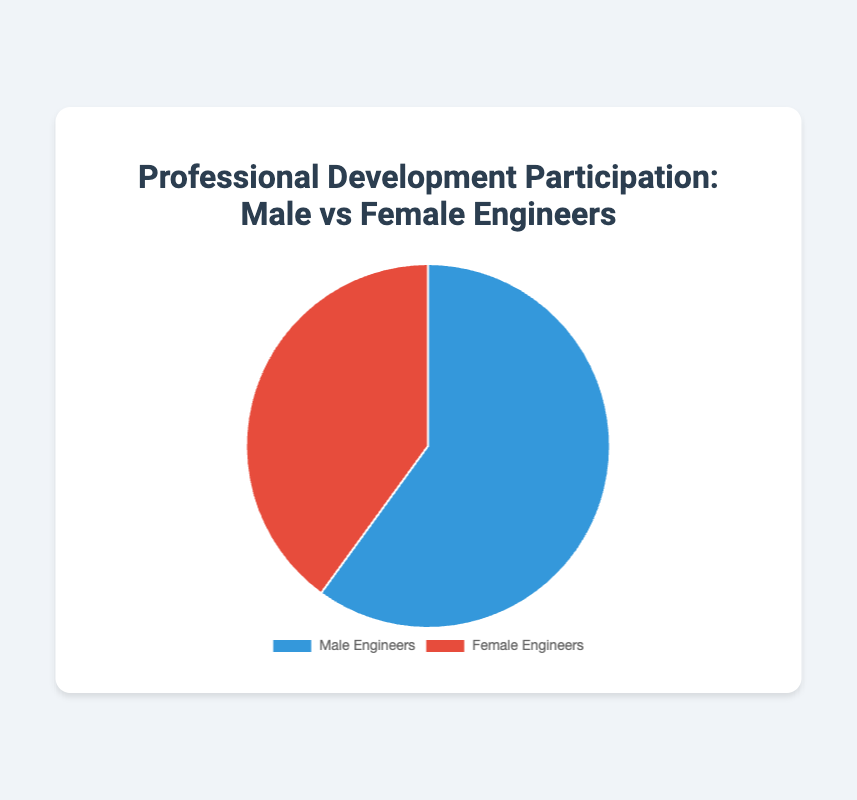What percentage of participants in professional development programs are Female Engineers? The total number of participants is 1200 (Male Engineers) + 800 (Female Engineers) = 2000. The percentage of Female Engineers is (800 / 2000) * 100 = 40%.
Answer: 40% What is the difference in participation between Male and Female Engineers? Male Engineers have 1200 participants and Female Engineers have 800 participants. The difference is 1200 - 800 = 400.
Answer: 400 What fraction of the total members are Male Engineers? The total number of participants is 2000. Male Engineers are 1200 out of 2000. Thus, the fraction is 1200 / 2000 = 3/5 or 0.6.
Answer: 3/5 or 0.6 Which gender has a larger share of participation in professional development programs? By comparing the two data points, Male Engineers (1200 participants) have a larger share compared to Female Engineers (800 participants).
Answer: Male Engineers If we add 200 more Female Engineers to the participation, will the number of Male Engineers still be higher? Currently, Male Engineers have 1200 participants and Female Engineers have 800 participants. Adding 200 more participants to Female Engineers gives 800 + 200 = 1000. Since 1000 is still less than 1200, Male Engineers will still have a higher number.
Answer: Yes What percentage of the pie chart is represented by Male Engineers? The total number of participants is 2000. The percentage for Male Engineers is (1200 / 2000) * 100 = 60%.
Answer: 60% What is the combined number of participants for both genders? Adding the participants from both genders: 1200 (Male Engineers) + 800 (Female Engineers) = 2000.
Answer: 2000 How many more Male Engineers are there compared to Female Engineers? Subtracting the number of Female Engineers from Male Engineers: 1200 - 800 = 400.
Answer: 400 If the pie chart were divided into quarters, how many quarters would represent Female Engineers? Female Engineers make up 40% of the pie, equivalent to 2/5 of a pie chart. Since a pie chart is divided into 4 quarters, Female Engineers represent 2/5 * 4 quarters = 1.6 quarters.
Answer: 1.6 quarters 